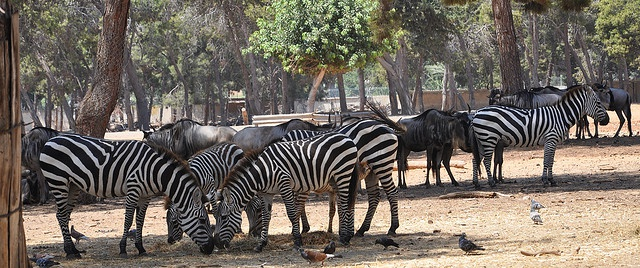Describe the objects in this image and their specific colors. I can see zebra in gray, black, and darkgray tones, zebra in gray, black, darkgray, and lightgray tones, zebra in gray, black, darkgray, and lightgray tones, zebra in gray, black, and darkgray tones, and zebra in gray, black, darkgray, and lightgray tones in this image. 